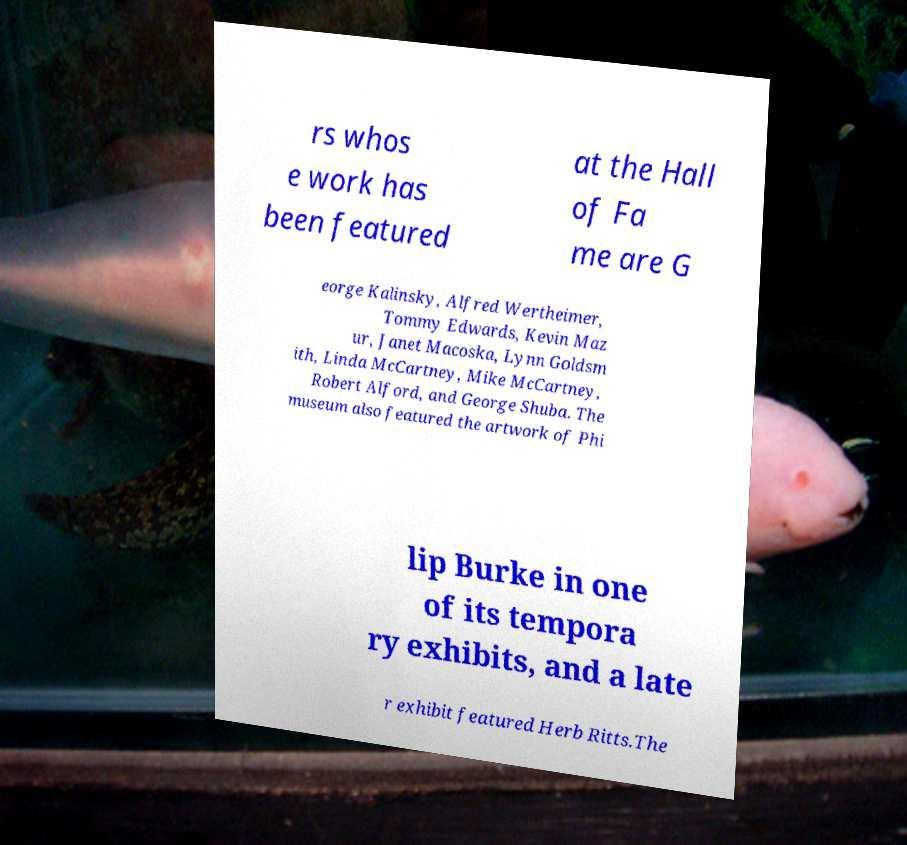Could you extract and type out the text from this image? rs whos e work has been featured at the Hall of Fa me are G eorge Kalinsky, Alfred Wertheimer, Tommy Edwards, Kevin Maz ur, Janet Macoska, Lynn Goldsm ith, Linda McCartney, Mike McCartney, Robert Alford, and George Shuba. The museum also featured the artwork of Phi lip Burke in one of its tempora ry exhibits, and a late r exhibit featured Herb Ritts.The 